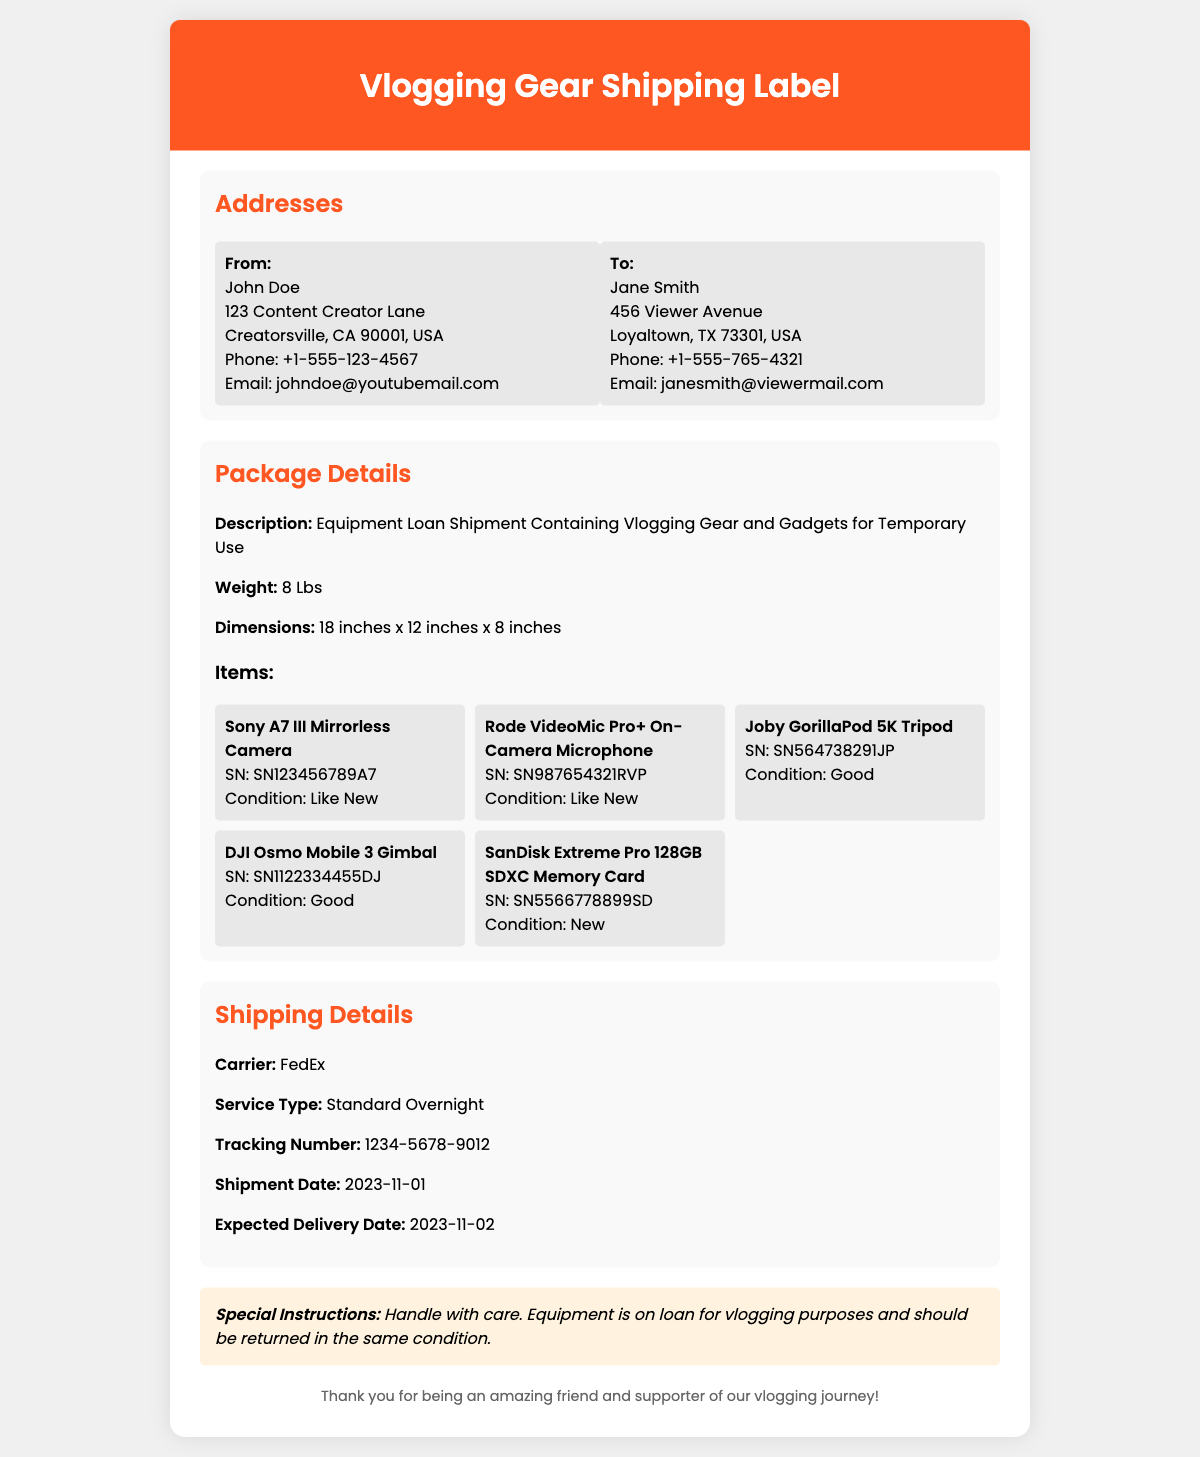What is the weight of the package? The weight of the package is explicitly stated in the document.
Answer: 8 Lbs Who is the sender? The sender's name is provided in the address section of the document.
Answer: John Doe What is the tracking number? The tracking number is specified in the shipping details section of the document.
Answer: 1234-5678-9012 What is the expected delivery date? The expected delivery date is mentioned in the shipping details of the document.
Answer: 2023-11-02 What is the condition of the SanDisk Extreme Pro 128GB SDXC Memory Card? The condition is stated in the items section for that specific item.
Answer: New What shipping carrier is used? The carrier's name is listed in the shipping details section of the document.
Answer: FedEx What kind of microphone is included in the shipment? The type of microphone is described in the items section with its details.
Answer: Rode VideoMic Pro+ On-Camera Microphone Why should the equipment be handled with care? The special instructions section explains the reasons for careful handling.
Answer: Equipment is on loan for vlogging purposes and should be returned in the same condition How many items are listed in the package details? The number of items can be counted based on the item entries provided.
Answer: 5 